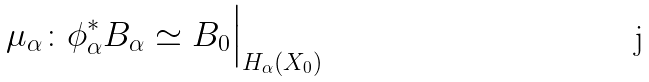Convert formula to latex. <formula><loc_0><loc_0><loc_500><loc_500>\mu _ { \alpha } \colon \phi _ { \alpha } ^ { * } B _ { \alpha } \simeq B _ { 0 } \Big | _ { H _ { \alpha } ( X _ { 0 } ) }</formula> 